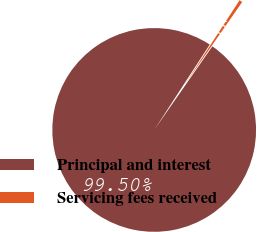Convert chart. <chart><loc_0><loc_0><loc_500><loc_500><pie_chart><fcel>Principal and interest<fcel>Servicing fees received<nl><fcel>99.5%<fcel>0.5%<nl></chart> 